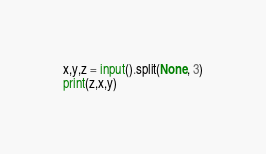Convert code to text. <code><loc_0><loc_0><loc_500><loc_500><_Python_>x,y,z = input().split(None, 3)
print(z,x,y)</code> 